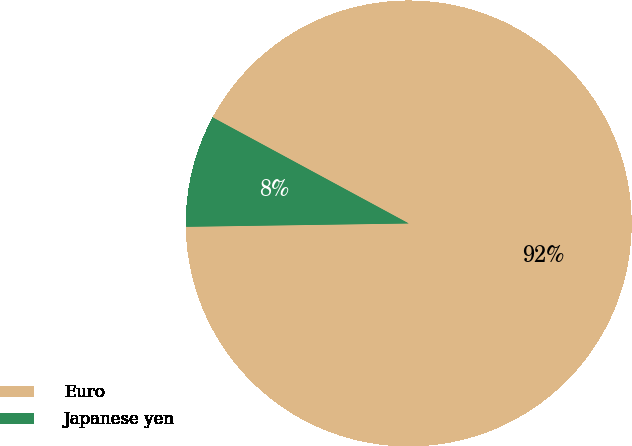Convert chart to OTSL. <chart><loc_0><loc_0><loc_500><loc_500><pie_chart><fcel>Euro<fcel>Japanese yen<nl><fcel>91.87%<fcel>8.13%<nl></chart> 